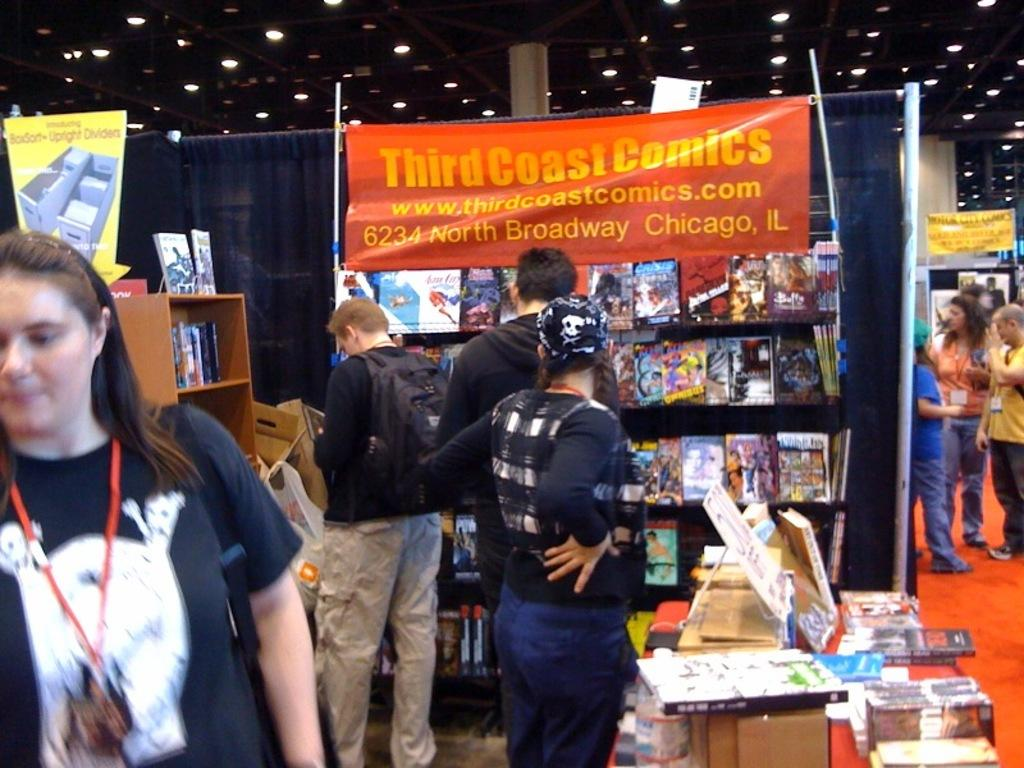<image>
Offer a succinct explanation of the picture presented. The picture shows what appears to be the third coast comics convention. 